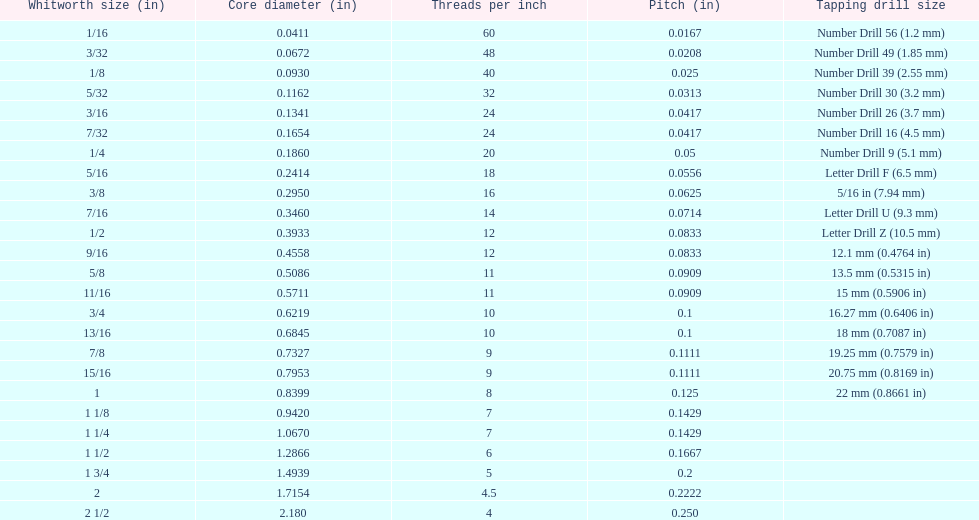What is the aggregate of the initial two core diameters? 0.1083. Can you parse all the data within this table? {'header': ['Whitworth size (in)', 'Core diameter (in)', 'Threads per\xa0inch', 'Pitch (in)', 'Tapping drill size'], 'rows': [['1/16', '0.0411', '60', '0.0167', 'Number Drill 56 (1.2\xa0mm)'], ['3/32', '0.0672', '48', '0.0208', 'Number Drill 49 (1.85\xa0mm)'], ['1/8', '0.0930', '40', '0.025', 'Number Drill 39 (2.55\xa0mm)'], ['5/32', '0.1162', '32', '0.0313', 'Number Drill 30 (3.2\xa0mm)'], ['3/16', '0.1341', '24', '0.0417', 'Number Drill 26 (3.7\xa0mm)'], ['7/32', '0.1654', '24', '0.0417', 'Number Drill 16 (4.5\xa0mm)'], ['1/4', '0.1860', '20', '0.05', 'Number Drill 9 (5.1\xa0mm)'], ['5/16', '0.2414', '18', '0.0556', 'Letter Drill F (6.5\xa0mm)'], ['3/8', '0.2950', '16', '0.0625', '5/16\xa0in (7.94\xa0mm)'], ['7/16', '0.3460', '14', '0.0714', 'Letter Drill U (9.3\xa0mm)'], ['1/2', '0.3933', '12', '0.0833', 'Letter Drill Z (10.5\xa0mm)'], ['9/16', '0.4558', '12', '0.0833', '12.1\xa0mm (0.4764\xa0in)'], ['5/8', '0.5086', '11', '0.0909', '13.5\xa0mm (0.5315\xa0in)'], ['11/16', '0.5711', '11', '0.0909', '15\xa0mm (0.5906\xa0in)'], ['3/4', '0.6219', '10', '0.1', '16.27\xa0mm (0.6406\xa0in)'], ['13/16', '0.6845', '10', '0.1', '18\xa0mm (0.7087\xa0in)'], ['7/8', '0.7327', '9', '0.1111', '19.25\xa0mm (0.7579\xa0in)'], ['15/16', '0.7953', '9', '0.1111', '20.75\xa0mm (0.8169\xa0in)'], ['1', '0.8399', '8', '0.125', '22\xa0mm (0.8661\xa0in)'], ['1 1/8', '0.9420', '7', '0.1429', ''], ['1 1/4', '1.0670', '7', '0.1429', ''], ['1 1/2', '1.2866', '6', '0.1667', ''], ['1 3/4', '1.4939', '5', '0.2', ''], ['2', '1.7154', '4.5', '0.2222', ''], ['2 1/2', '2.180', '4', '0.250', '']]} 